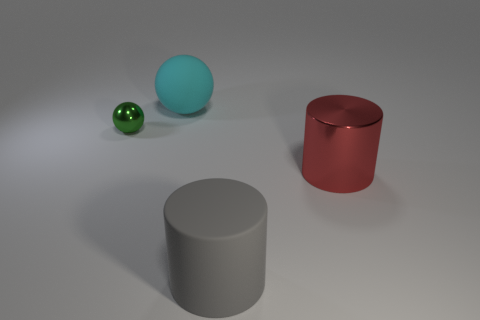What number of cylinders are either tiny gray things or rubber objects?
Provide a succinct answer. 1. There is a big thing that is both behind the big gray rubber thing and on the right side of the matte ball; what shape is it?
Your response must be concise. Cylinder. Are there any gray things of the same size as the metallic cylinder?
Provide a short and direct response. Yes. What number of objects are metallic objects that are to the left of the large gray matte thing or big cyan rubber objects?
Give a very brief answer. 2. Are the gray thing and the ball that is to the right of the small green object made of the same material?
Offer a terse response. Yes. What number of other things are the same shape as the cyan matte thing?
Your answer should be very brief. 1. How many things are objects that are behind the large red cylinder or gray cylinders that are in front of the large red cylinder?
Keep it short and to the point. 3. How many other things are there of the same color as the tiny sphere?
Offer a very short reply. 0. Is the number of gray things behind the matte sphere less than the number of large matte objects behind the big gray thing?
Ensure brevity in your answer.  Yes. What number of gray things are there?
Ensure brevity in your answer.  1. 